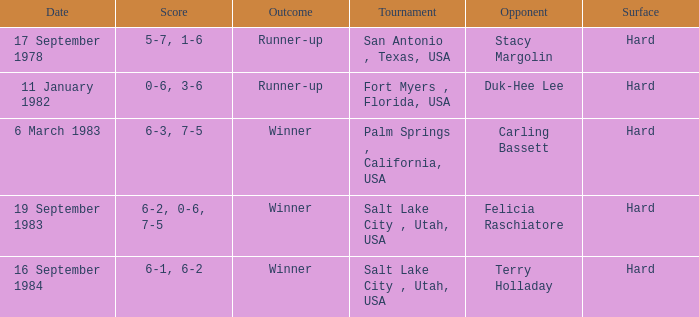What was the score of the match against duk-hee lee? 0-6, 3-6. 